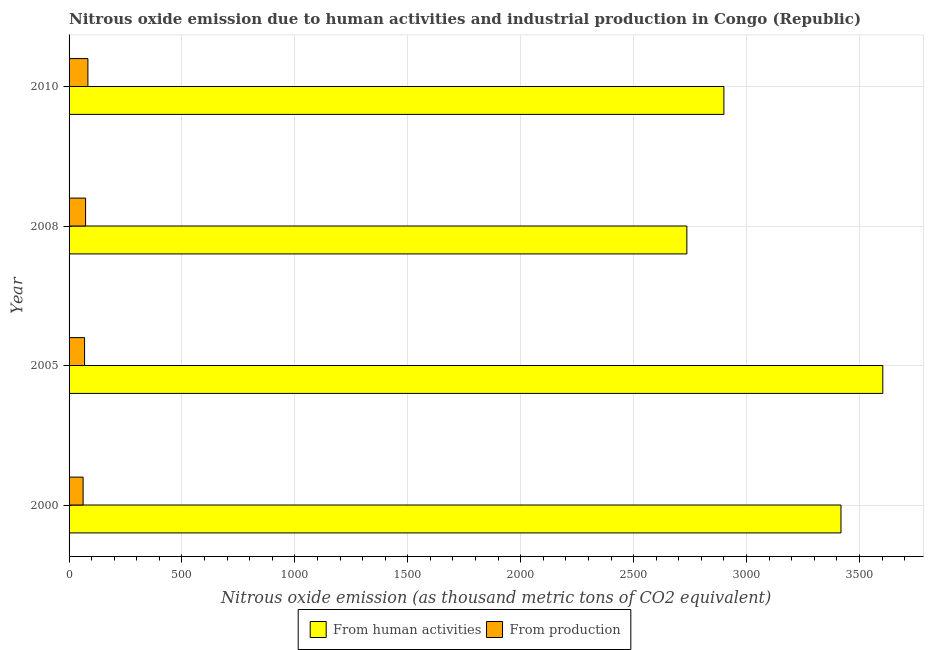Are the number of bars per tick equal to the number of legend labels?
Your answer should be very brief. Yes. Are the number of bars on each tick of the Y-axis equal?
Your answer should be compact. Yes. How many bars are there on the 3rd tick from the top?
Provide a short and direct response. 2. How many bars are there on the 2nd tick from the bottom?
Provide a succinct answer. 2. In how many cases, is the number of bars for a given year not equal to the number of legend labels?
Give a very brief answer. 0. What is the amount of emissions generated from industries in 2010?
Give a very brief answer. 83.4. Across all years, what is the maximum amount of emissions generated from industries?
Keep it short and to the point. 83.4. Across all years, what is the minimum amount of emissions from human activities?
Ensure brevity in your answer.  2735.8. In which year was the amount of emissions generated from industries minimum?
Your answer should be compact. 2000. What is the total amount of emissions generated from industries in the graph?
Your answer should be compact. 287.5. What is the difference between the amount of emissions from human activities in 2005 and that in 2008?
Offer a very short reply. 867.7. What is the difference between the amount of emissions generated from industries in 2000 and the amount of emissions from human activities in 2005?
Make the answer very short. -3541.3. What is the average amount of emissions from human activities per year?
Provide a succinct answer. 3164.35. In the year 2008, what is the difference between the amount of emissions generated from industries and amount of emissions from human activities?
Your answer should be compact. -2662.6. What is the ratio of the amount of emissions generated from industries in 2005 to that in 2008?
Offer a terse response. 0.94. Is the difference between the amount of emissions from human activities in 2008 and 2010 greater than the difference between the amount of emissions generated from industries in 2008 and 2010?
Offer a terse response. No. What is the difference between the highest and the second highest amount of emissions from human activities?
Provide a short and direct response. 185.2. What is the difference between the highest and the lowest amount of emissions generated from industries?
Your answer should be compact. 21.2. In how many years, is the amount of emissions generated from industries greater than the average amount of emissions generated from industries taken over all years?
Your response must be concise. 2. What does the 2nd bar from the top in 2005 represents?
Your answer should be compact. From human activities. What does the 2nd bar from the bottom in 2010 represents?
Your response must be concise. From production. How many bars are there?
Offer a terse response. 8. How many years are there in the graph?
Offer a very short reply. 4. What is the difference between two consecutive major ticks on the X-axis?
Your answer should be very brief. 500. Does the graph contain grids?
Your response must be concise. Yes. Where does the legend appear in the graph?
Offer a very short reply. Bottom center. How are the legend labels stacked?
Offer a terse response. Horizontal. What is the title of the graph?
Ensure brevity in your answer.  Nitrous oxide emission due to human activities and industrial production in Congo (Republic). Does "Primary" appear as one of the legend labels in the graph?
Your answer should be very brief. No. What is the label or title of the X-axis?
Make the answer very short. Nitrous oxide emission (as thousand metric tons of CO2 equivalent). What is the Nitrous oxide emission (as thousand metric tons of CO2 equivalent) in From human activities in 2000?
Offer a very short reply. 3418.3. What is the Nitrous oxide emission (as thousand metric tons of CO2 equivalent) of From production in 2000?
Provide a short and direct response. 62.2. What is the Nitrous oxide emission (as thousand metric tons of CO2 equivalent) of From human activities in 2005?
Offer a terse response. 3603.5. What is the Nitrous oxide emission (as thousand metric tons of CO2 equivalent) of From production in 2005?
Your answer should be very brief. 68.7. What is the Nitrous oxide emission (as thousand metric tons of CO2 equivalent) of From human activities in 2008?
Your response must be concise. 2735.8. What is the Nitrous oxide emission (as thousand metric tons of CO2 equivalent) of From production in 2008?
Offer a very short reply. 73.2. What is the Nitrous oxide emission (as thousand metric tons of CO2 equivalent) of From human activities in 2010?
Ensure brevity in your answer.  2899.8. What is the Nitrous oxide emission (as thousand metric tons of CO2 equivalent) in From production in 2010?
Give a very brief answer. 83.4. Across all years, what is the maximum Nitrous oxide emission (as thousand metric tons of CO2 equivalent) in From human activities?
Offer a very short reply. 3603.5. Across all years, what is the maximum Nitrous oxide emission (as thousand metric tons of CO2 equivalent) of From production?
Your answer should be very brief. 83.4. Across all years, what is the minimum Nitrous oxide emission (as thousand metric tons of CO2 equivalent) in From human activities?
Your answer should be very brief. 2735.8. Across all years, what is the minimum Nitrous oxide emission (as thousand metric tons of CO2 equivalent) in From production?
Provide a short and direct response. 62.2. What is the total Nitrous oxide emission (as thousand metric tons of CO2 equivalent) of From human activities in the graph?
Keep it short and to the point. 1.27e+04. What is the total Nitrous oxide emission (as thousand metric tons of CO2 equivalent) in From production in the graph?
Provide a short and direct response. 287.5. What is the difference between the Nitrous oxide emission (as thousand metric tons of CO2 equivalent) in From human activities in 2000 and that in 2005?
Your answer should be very brief. -185.2. What is the difference between the Nitrous oxide emission (as thousand metric tons of CO2 equivalent) of From human activities in 2000 and that in 2008?
Make the answer very short. 682.5. What is the difference between the Nitrous oxide emission (as thousand metric tons of CO2 equivalent) in From human activities in 2000 and that in 2010?
Your answer should be compact. 518.5. What is the difference between the Nitrous oxide emission (as thousand metric tons of CO2 equivalent) in From production in 2000 and that in 2010?
Make the answer very short. -21.2. What is the difference between the Nitrous oxide emission (as thousand metric tons of CO2 equivalent) of From human activities in 2005 and that in 2008?
Your answer should be compact. 867.7. What is the difference between the Nitrous oxide emission (as thousand metric tons of CO2 equivalent) in From human activities in 2005 and that in 2010?
Your answer should be very brief. 703.7. What is the difference between the Nitrous oxide emission (as thousand metric tons of CO2 equivalent) in From production in 2005 and that in 2010?
Make the answer very short. -14.7. What is the difference between the Nitrous oxide emission (as thousand metric tons of CO2 equivalent) of From human activities in 2008 and that in 2010?
Your answer should be very brief. -164. What is the difference between the Nitrous oxide emission (as thousand metric tons of CO2 equivalent) in From human activities in 2000 and the Nitrous oxide emission (as thousand metric tons of CO2 equivalent) in From production in 2005?
Give a very brief answer. 3349.6. What is the difference between the Nitrous oxide emission (as thousand metric tons of CO2 equivalent) of From human activities in 2000 and the Nitrous oxide emission (as thousand metric tons of CO2 equivalent) of From production in 2008?
Make the answer very short. 3345.1. What is the difference between the Nitrous oxide emission (as thousand metric tons of CO2 equivalent) of From human activities in 2000 and the Nitrous oxide emission (as thousand metric tons of CO2 equivalent) of From production in 2010?
Offer a terse response. 3334.9. What is the difference between the Nitrous oxide emission (as thousand metric tons of CO2 equivalent) of From human activities in 2005 and the Nitrous oxide emission (as thousand metric tons of CO2 equivalent) of From production in 2008?
Your answer should be very brief. 3530.3. What is the difference between the Nitrous oxide emission (as thousand metric tons of CO2 equivalent) in From human activities in 2005 and the Nitrous oxide emission (as thousand metric tons of CO2 equivalent) in From production in 2010?
Keep it short and to the point. 3520.1. What is the difference between the Nitrous oxide emission (as thousand metric tons of CO2 equivalent) of From human activities in 2008 and the Nitrous oxide emission (as thousand metric tons of CO2 equivalent) of From production in 2010?
Give a very brief answer. 2652.4. What is the average Nitrous oxide emission (as thousand metric tons of CO2 equivalent) of From human activities per year?
Provide a short and direct response. 3164.35. What is the average Nitrous oxide emission (as thousand metric tons of CO2 equivalent) in From production per year?
Offer a very short reply. 71.88. In the year 2000, what is the difference between the Nitrous oxide emission (as thousand metric tons of CO2 equivalent) of From human activities and Nitrous oxide emission (as thousand metric tons of CO2 equivalent) of From production?
Your answer should be very brief. 3356.1. In the year 2005, what is the difference between the Nitrous oxide emission (as thousand metric tons of CO2 equivalent) of From human activities and Nitrous oxide emission (as thousand metric tons of CO2 equivalent) of From production?
Provide a succinct answer. 3534.8. In the year 2008, what is the difference between the Nitrous oxide emission (as thousand metric tons of CO2 equivalent) of From human activities and Nitrous oxide emission (as thousand metric tons of CO2 equivalent) of From production?
Keep it short and to the point. 2662.6. In the year 2010, what is the difference between the Nitrous oxide emission (as thousand metric tons of CO2 equivalent) of From human activities and Nitrous oxide emission (as thousand metric tons of CO2 equivalent) of From production?
Provide a short and direct response. 2816.4. What is the ratio of the Nitrous oxide emission (as thousand metric tons of CO2 equivalent) in From human activities in 2000 to that in 2005?
Offer a very short reply. 0.95. What is the ratio of the Nitrous oxide emission (as thousand metric tons of CO2 equivalent) in From production in 2000 to that in 2005?
Ensure brevity in your answer.  0.91. What is the ratio of the Nitrous oxide emission (as thousand metric tons of CO2 equivalent) in From human activities in 2000 to that in 2008?
Make the answer very short. 1.25. What is the ratio of the Nitrous oxide emission (as thousand metric tons of CO2 equivalent) of From production in 2000 to that in 2008?
Ensure brevity in your answer.  0.85. What is the ratio of the Nitrous oxide emission (as thousand metric tons of CO2 equivalent) in From human activities in 2000 to that in 2010?
Ensure brevity in your answer.  1.18. What is the ratio of the Nitrous oxide emission (as thousand metric tons of CO2 equivalent) in From production in 2000 to that in 2010?
Offer a terse response. 0.75. What is the ratio of the Nitrous oxide emission (as thousand metric tons of CO2 equivalent) of From human activities in 2005 to that in 2008?
Give a very brief answer. 1.32. What is the ratio of the Nitrous oxide emission (as thousand metric tons of CO2 equivalent) in From production in 2005 to that in 2008?
Provide a short and direct response. 0.94. What is the ratio of the Nitrous oxide emission (as thousand metric tons of CO2 equivalent) in From human activities in 2005 to that in 2010?
Provide a short and direct response. 1.24. What is the ratio of the Nitrous oxide emission (as thousand metric tons of CO2 equivalent) in From production in 2005 to that in 2010?
Offer a very short reply. 0.82. What is the ratio of the Nitrous oxide emission (as thousand metric tons of CO2 equivalent) of From human activities in 2008 to that in 2010?
Keep it short and to the point. 0.94. What is the ratio of the Nitrous oxide emission (as thousand metric tons of CO2 equivalent) of From production in 2008 to that in 2010?
Provide a succinct answer. 0.88. What is the difference between the highest and the second highest Nitrous oxide emission (as thousand metric tons of CO2 equivalent) of From human activities?
Give a very brief answer. 185.2. What is the difference between the highest and the second highest Nitrous oxide emission (as thousand metric tons of CO2 equivalent) of From production?
Your answer should be compact. 10.2. What is the difference between the highest and the lowest Nitrous oxide emission (as thousand metric tons of CO2 equivalent) of From human activities?
Make the answer very short. 867.7. What is the difference between the highest and the lowest Nitrous oxide emission (as thousand metric tons of CO2 equivalent) of From production?
Ensure brevity in your answer.  21.2. 